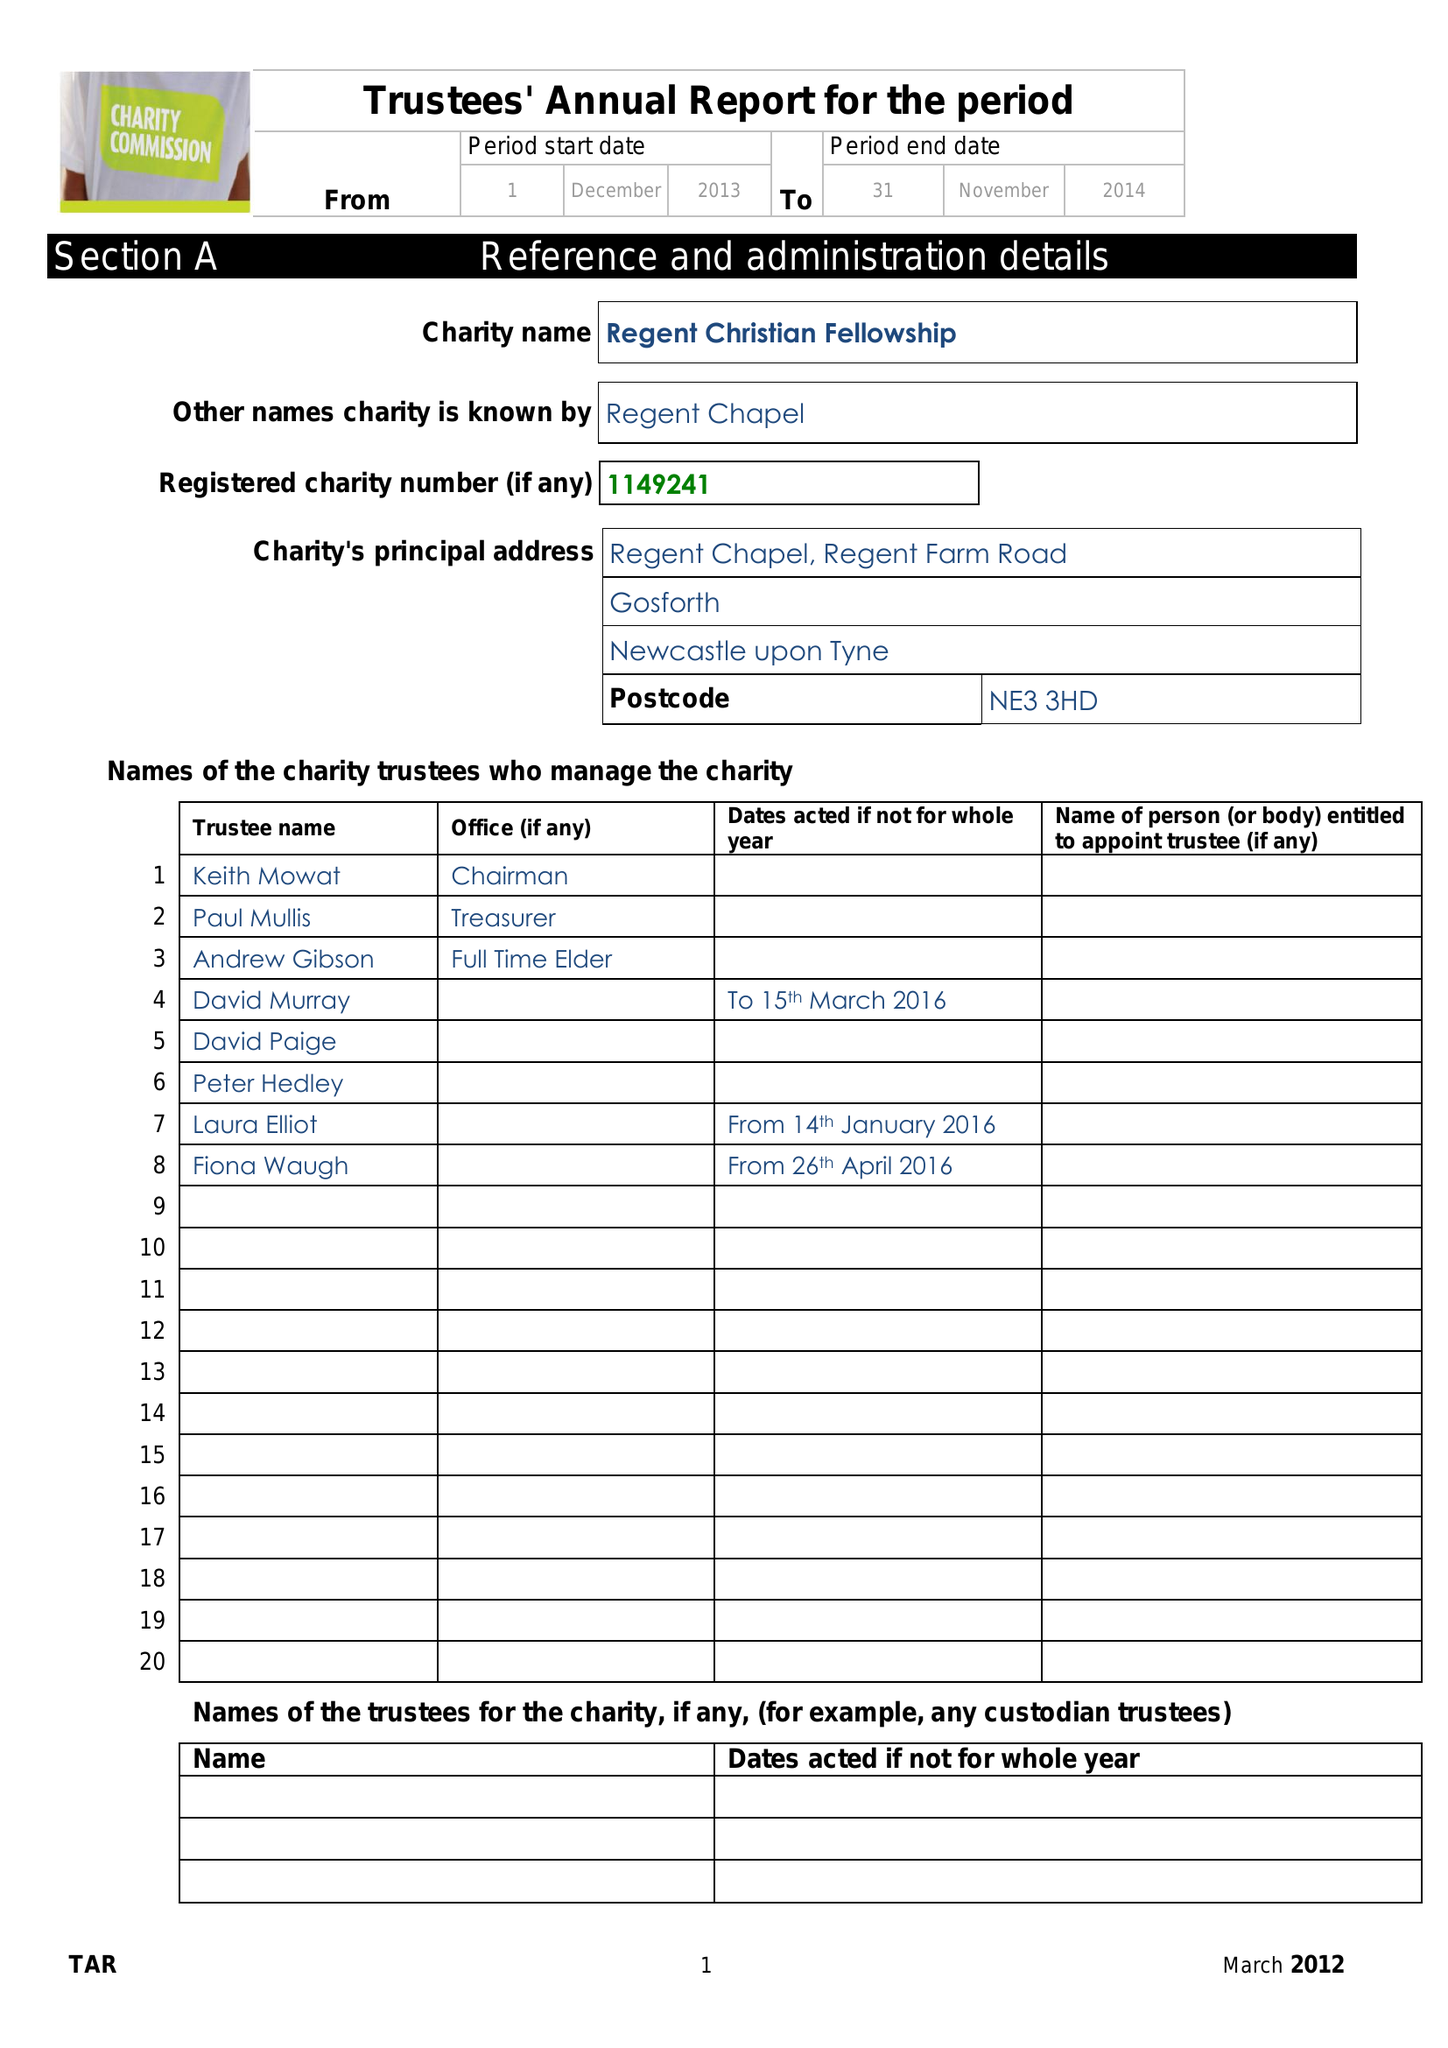What is the value for the spending_annually_in_british_pounds?
Answer the question using a single word or phrase. 98644.00 